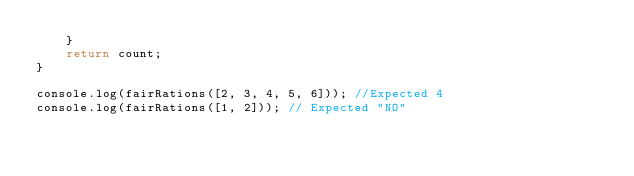<code> <loc_0><loc_0><loc_500><loc_500><_JavaScript_>    }
    return count;
}

console.log(fairRations([2, 3, 4, 5, 6])); //Expected 4
console.log(fairRations([1, 2])); // Expected "NO"</code> 